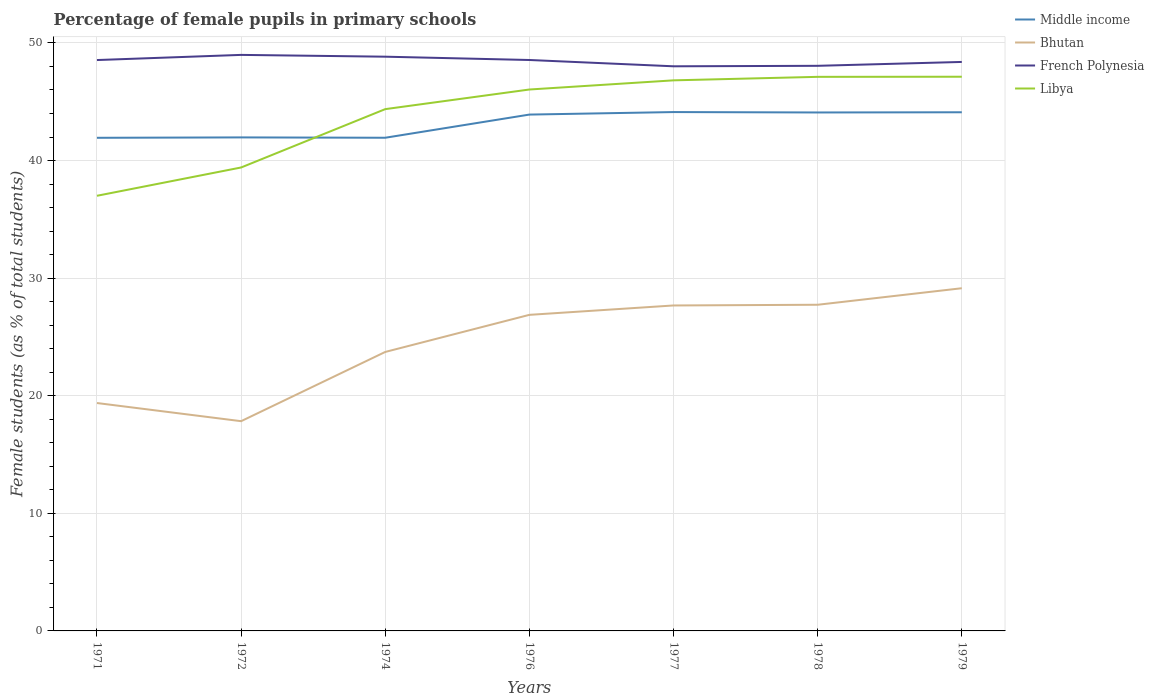Does the line corresponding to Bhutan intersect with the line corresponding to Middle income?
Keep it short and to the point. No. Is the number of lines equal to the number of legend labels?
Your response must be concise. Yes. Across all years, what is the maximum percentage of female pupils in primary schools in Bhutan?
Provide a succinct answer. 17.84. What is the total percentage of female pupils in primary schools in Bhutan in the graph?
Your answer should be compact. -9.84. What is the difference between the highest and the second highest percentage of female pupils in primary schools in Middle income?
Offer a terse response. 2.19. What is the difference between the highest and the lowest percentage of female pupils in primary schools in Middle income?
Make the answer very short. 4. Is the percentage of female pupils in primary schools in Middle income strictly greater than the percentage of female pupils in primary schools in Libya over the years?
Your answer should be very brief. No. How many years are there in the graph?
Make the answer very short. 7. Are the values on the major ticks of Y-axis written in scientific E-notation?
Your response must be concise. No. Does the graph contain any zero values?
Offer a terse response. No. Does the graph contain grids?
Provide a succinct answer. Yes. How many legend labels are there?
Offer a terse response. 4. What is the title of the graph?
Offer a very short reply. Percentage of female pupils in primary schools. What is the label or title of the Y-axis?
Make the answer very short. Female students (as % of total students). What is the Female students (as % of total students) of Middle income in 1971?
Offer a very short reply. 41.93. What is the Female students (as % of total students) in Bhutan in 1971?
Make the answer very short. 19.38. What is the Female students (as % of total students) in French Polynesia in 1971?
Your answer should be very brief. 48.55. What is the Female students (as % of total students) of Libya in 1971?
Give a very brief answer. 37. What is the Female students (as % of total students) in Middle income in 1972?
Make the answer very short. 41.97. What is the Female students (as % of total students) of Bhutan in 1972?
Make the answer very short. 17.84. What is the Female students (as % of total students) in French Polynesia in 1972?
Offer a very short reply. 48.98. What is the Female students (as % of total students) in Libya in 1972?
Offer a terse response. 39.41. What is the Female students (as % of total students) of Middle income in 1974?
Offer a very short reply. 41.94. What is the Female students (as % of total students) of Bhutan in 1974?
Keep it short and to the point. 23.72. What is the Female students (as % of total students) in French Polynesia in 1974?
Your answer should be compact. 48.83. What is the Female students (as % of total students) in Libya in 1974?
Provide a succinct answer. 44.37. What is the Female students (as % of total students) in Middle income in 1976?
Offer a terse response. 43.91. What is the Female students (as % of total students) in Bhutan in 1976?
Offer a very short reply. 26.88. What is the Female students (as % of total students) of French Polynesia in 1976?
Your response must be concise. 48.55. What is the Female students (as % of total students) in Libya in 1976?
Give a very brief answer. 46.04. What is the Female students (as % of total students) of Middle income in 1977?
Provide a short and direct response. 44.12. What is the Female students (as % of total students) in Bhutan in 1977?
Provide a short and direct response. 27.68. What is the Female students (as % of total students) in French Polynesia in 1977?
Offer a terse response. 48.01. What is the Female students (as % of total students) of Libya in 1977?
Your answer should be very brief. 46.82. What is the Female students (as % of total students) in Middle income in 1978?
Your answer should be compact. 44.09. What is the Female students (as % of total students) of Bhutan in 1978?
Offer a very short reply. 27.74. What is the Female students (as % of total students) in French Polynesia in 1978?
Ensure brevity in your answer.  48.06. What is the Female students (as % of total students) in Libya in 1978?
Offer a terse response. 47.12. What is the Female students (as % of total students) in Middle income in 1979?
Make the answer very short. 44.11. What is the Female students (as % of total students) in Bhutan in 1979?
Provide a succinct answer. 29.14. What is the Female students (as % of total students) of French Polynesia in 1979?
Your response must be concise. 48.39. What is the Female students (as % of total students) in Libya in 1979?
Offer a terse response. 47.13. Across all years, what is the maximum Female students (as % of total students) in Middle income?
Your response must be concise. 44.12. Across all years, what is the maximum Female students (as % of total students) of Bhutan?
Provide a succinct answer. 29.14. Across all years, what is the maximum Female students (as % of total students) of French Polynesia?
Your answer should be very brief. 48.98. Across all years, what is the maximum Female students (as % of total students) of Libya?
Provide a short and direct response. 47.13. Across all years, what is the minimum Female students (as % of total students) in Middle income?
Keep it short and to the point. 41.93. Across all years, what is the minimum Female students (as % of total students) of Bhutan?
Offer a very short reply. 17.84. Across all years, what is the minimum Female students (as % of total students) of French Polynesia?
Your answer should be compact. 48.01. Across all years, what is the minimum Female students (as % of total students) of Libya?
Offer a very short reply. 37. What is the total Female students (as % of total students) in Middle income in the graph?
Keep it short and to the point. 302.07. What is the total Female students (as % of total students) of Bhutan in the graph?
Your answer should be compact. 172.37. What is the total Female students (as % of total students) in French Polynesia in the graph?
Your response must be concise. 339.37. What is the total Female students (as % of total students) of Libya in the graph?
Your answer should be compact. 307.89. What is the difference between the Female students (as % of total students) of Middle income in 1971 and that in 1972?
Provide a succinct answer. -0.03. What is the difference between the Female students (as % of total students) in Bhutan in 1971 and that in 1972?
Offer a very short reply. 1.54. What is the difference between the Female students (as % of total students) of French Polynesia in 1971 and that in 1972?
Ensure brevity in your answer.  -0.44. What is the difference between the Female students (as % of total students) of Libya in 1971 and that in 1972?
Give a very brief answer. -2.41. What is the difference between the Female students (as % of total students) of Middle income in 1971 and that in 1974?
Your response must be concise. -0.01. What is the difference between the Female students (as % of total students) of Bhutan in 1971 and that in 1974?
Offer a terse response. -4.34. What is the difference between the Female students (as % of total students) in French Polynesia in 1971 and that in 1974?
Your answer should be very brief. -0.29. What is the difference between the Female students (as % of total students) in Libya in 1971 and that in 1974?
Provide a succinct answer. -7.37. What is the difference between the Female students (as % of total students) of Middle income in 1971 and that in 1976?
Give a very brief answer. -1.97. What is the difference between the Female students (as % of total students) in Bhutan in 1971 and that in 1976?
Offer a terse response. -7.5. What is the difference between the Female students (as % of total students) in French Polynesia in 1971 and that in 1976?
Offer a very short reply. -0. What is the difference between the Female students (as % of total students) of Libya in 1971 and that in 1976?
Your response must be concise. -9.04. What is the difference between the Female students (as % of total students) in Middle income in 1971 and that in 1977?
Give a very brief answer. -2.19. What is the difference between the Female students (as % of total students) in Bhutan in 1971 and that in 1977?
Give a very brief answer. -8.3. What is the difference between the Female students (as % of total students) of French Polynesia in 1971 and that in 1977?
Your answer should be very brief. 0.53. What is the difference between the Female students (as % of total students) of Libya in 1971 and that in 1977?
Offer a terse response. -9.82. What is the difference between the Female students (as % of total students) of Middle income in 1971 and that in 1978?
Keep it short and to the point. -2.15. What is the difference between the Female students (as % of total students) in Bhutan in 1971 and that in 1978?
Keep it short and to the point. -8.36. What is the difference between the Female students (as % of total students) of French Polynesia in 1971 and that in 1978?
Keep it short and to the point. 0.49. What is the difference between the Female students (as % of total students) in Libya in 1971 and that in 1978?
Offer a very short reply. -10.11. What is the difference between the Female students (as % of total students) of Middle income in 1971 and that in 1979?
Offer a terse response. -2.17. What is the difference between the Female students (as % of total students) in Bhutan in 1971 and that in 1979?
Your answer should be very brief. -9.76. What is the difference between the Female students (as % of total students) in French Polynesia in 1971 and that in 1979?
Keep it short and to the point. 0.16. What is the difference between the Female students (as % of total students) of Libya in 1971 and that in 1979?
Keep it short and to the point. -10.12. What is the difference between the Female students (as % of total students) of Middle income in 1972 and that in 1974?
Provide a short and direct response. 0.03. What is the difference between the Female students (as % of total students) in Bhutan in 1972 and that in 1974?
Your answer should be very brief. -5.89. What is the difference between the Female students (as % of total students) of French Polynesia in 1972 and that in 1974?
Provide a short and direct response. 0.15. What is the difference between the Female students (as % of total students) in Libya in 1972 and that in 1974?
Offer a very short reply. -4.96. What is the difference between the Female students (as % of total students) of Middle income in 1972 and that in 1976?
Offer a very short reply. -1.94. What is the difference between the Female students (as % of total students) of Bhutan in 1972 and that in 1976?
Keep it short and to the point. -9.04. What is the difference between the Female students (as % of total students) of French Polynesia in 1972 and that in 1976?
Keep it short and to the point. 0.43. What is the difference between the Female students (as % of total students) of Libya in 1972 and that in 1976?
Offer a terse response. -6.63. What is the difference between the Female students (as % of total students) in Middle income in 1972 and that in 1977?
Offer a very short reply. -2.15. What is the difference between the Female students (as % of total students) in Bhutan in 1972 and that in 1977?
Give a very brief answer. -9.84. What is the difference between the Female students (as % of total students) in French Polynesia in 1972 and that in 1977?
Offer a terse response. 0.97. What is the difference between the Female students (as % of total students) in Libya in 1972 and that in 1977?
Your response must be concise. -7.41. What is the difference between the Female students (as % of total students) of Middle income in 1972 and that in 1978?
Ensure brevity in your answer.  -2.12. What is the difference between the Female students (as % of total students) in Bhutan in 1972 and that in 1978?
Your answer should be compact. -9.9. What is the difference between the Female students (as % of total students) in French Polynesia in 1972 and that in 1978?
Make the answer very short. 0.93. What is the difference between the Female students (as % of total students) of Libya in 1972 and that in 1978?
Provide a short and direct response. -7.71. What is the difference between the Female students (as % of total students) of Middle income in 1972 and that in 1979?
Offer a very short reply. -2.14. What is the difference between the Female students (as % of total students) of Bhutan in 1972 and that in 1979?
Keep it short and to the point. -11.31. What is the difference between the Female students (as % of total students) of French Polynesia in 1972 and that in 1979?
Ensure brevity in your answer.  0.6. What is the difference between the Female students (as % of total students) in Libya in 1972 and that in 1979?
Provide a short and direct response. -7.72. What is the difference between the Female students (as % of total students) in Middle income in 1974 and that in 1976?
Your answer should be compact. -1.97. What is the difference between the Female students (as % of total students) in Bhutan in 1974 and that in 1976?
Your response must be concise. -3.16. What is the difference between the Female students (as % of total students) in French Polynesia in 1974 and that in 1976?
Offer a terse response. 0.28. What is the difference between the Female students (as % of total students) of Libya in 1974 and that in 1976?
Provide a succinct answer. -1.67. What is the difference between the Female students (as % of total students) in Middle income in 1974 and that in 1977?
Your answer should be compact. -2.18. What is the difference between the Female students (as % of total students) of Bhutan in 1974 and that in 1977?
Ensure brevity in your answer.  -3.95. What is the difference between the Female students (as % of total students) in French Polynesia in 1974 and that in 1977?
Provide a short and direct response. 0.82. What is the difference between the Female students (as % of total students) of Libya in 1974 and that in 1977?
Offer a terse response. -2.45. What is the difference between the Female students (as % of total students) of Middle income in 1974 and that in 1978?
Ensure brevity in your answer.  -2.15. What is the difference between the Female students (as % of total students) of Bhutan in 1974 and that in 1978?
Provide a short and direct response. -4.01. What is the difference between the Female students (as % of total students) in French Polynesia in 1974 and that in 1978?
Your answer should be very brief. 0.78. What is the difference between the Female students (as % of total students) in Libya in 1974 and that in 1978?
Offer a very short reply. -2.75. What is the difference between the Female students (as % of total students) of Middle income in 1974 and that in 1979?
Your answer should be compact. -2.17. What is the difference between the Female students (as % of total students) of Bhutan in 1974 and that in 1979?
Keep it short and to the point. -5.42. What is the difference between the Female students (as % of total students) of French Polynesia in 1974 and that in 1979?
Make the answer very short. 0.45. What is the difference between the Female students (as % of total students) in Libya in 1974 and that in 1979?
Your answer should be compact. -2.75. What is the difference between the Female students (as % of total students) in Middle income in 1976 and that in 1977?
Provide a succinct answer. -0.21. What is the difference between the Female students (as % of total students) of Bhutan in 1976 and that in 1977?
Give a very brief answer. -0.8. What is the difference between the Female students (as % of total students) in French Polynesia in 1976 and that in 1977?
Provide a short and direct response. 0.54. What is the difference between the Female students (as % of total students) of Libya in 1976 and that in 1977?
Your response must be concise. -0.78. What is the difference between the Female students (as % of total students) of Middle income in 1976 and that in 1978?
Keep it short and to the point. -0.18. What is the difference between the Female students (as % of total students) of Bhutan in 1976 and that in 1978?
Your response must be concise. -0.86. What is the difference between the Female students (as % of total students) in French Polynesia in 1976 and that in 1978?
Offer a very short reply. 0.49. What is the difference between the Female students (as % of total students) of Libya in 1976 and that in 1978?
Keep it short and to the point. -1.08. What is the difference between the Female students (as % of total students) in Middle income in 1976 and that in 1979?
Provide a succinct answer. -0.2. What is the difference between the Female students (as % of total students) in Bhutan in 1976 and that in 1979?
Offer a terse response. -2.26. What is the difference between the Female students (as % of total students) in French Polynesia in 1976 and that in 1979?
Provide a succinct answer. 0.17. What is the difference between the Female students (as % of total students) of Libya in 1976 and that in 1979?
Ensure brevity in your answer.  -1.09. What is the difference between the Female students (as % of total students) in Middle income in 1977 and that in 1978?
Make the answer very short. 0.03. What is the difference between the Female students (as % of total students) of Bhutan in 1977 and that in 1978?
Your answer should be compact. -0.06. What is the difference between the Female students (as % of total students) in French Polynesia in 1977 and that in 1978?
Offer a terse response. -0.04. What is the difference between the Female students (as % of total students) of Libya in 1977 and that in 1978?
Provide a succinct answer. -0.3. What is the difference between the Female students (as % of total students) of Middle income in 1977 and that in 1979?
Offer a very short reply. 0.02. What is the difference between the Female students (as % of total students) of Bhutan in 1977 and that in 1979?
Give a very brief answer. -1.47. What is the difference between the Female students (as % of total students) of French Polynesia in 1977 and that in 1979?
Give a very brief answer. -0.37. What is the difference between the Female students (as % of total students) of Libya in 1977 and that in 1979?
Give a very brief answer. -0.31. What is the difference between the Female students (as % of total students) of Middle income in 1978 and that in 1979?
Your response must be concise. -0.02. What is the difference between the Female students (as % of total students) of Bhutan in 1978 and that in 1979?
Offer a very short reply. -1.41. What is the difference between the Female students (as % of total students) in French Polynesia in 1978 and that in 1979?
Offer a terse response. -0.33. What is the difference between the Female students (as % of total students) in Libya in 1978 and that in 1979?
Your response must be concise. -0.01. What is the difference between the Female students (as % of total students) of Middle income in 1971 and the Female students (as % of total students) of Bhutan in 1972?
Make the answer very short. 24.1. What is the difference between the Female students (as % of total students) in Middle income in 1971 and the Female students (as % of total students) in French Polynesia in 1972?
Keep it short and to the point. -7.05. What is the difference between the Female students (as % of total students) of Middle income in 1971 and the Female students (as % of total students) of Libya in 1972?
Keep it short and to the point. 2.52. What is the difference between the Female students (as % of total students) of Bhutan in 1971 and the Female students (as % of total students) of French Polynesia in 1972?
Give a very brief answer. -29.6. What is the difference between the Female students (as % of total students) of Bhutan in 1971 and the Female students (as % of total students) of Libya in 1972?
Your answer should be very brief. -20.03. What is the difference between the Female students (as % of total students) in French Polynesia in 1971 and the Female students (as % of total students) in Libya in 1972?
Provide a succinct answer. 9.14. What is the difference between the Female students (as % of total students) in Middle income in 1971 and the Female students (as % of total students) in Bhutan in 1974?
Your response must be concise. 18.21. What is the difference between the Female students (as % of total students) of Middle income in 1971 and the Female students (as % of total students) of French Polynesia in 1974?
Offer a very short reply. -6.9. What is the difference between the Female students (as % of total students) in Middle income in 1971 and the Female students (as % of total students) in Libya in 1974?
Provide a succinct answer. -2.44. What is the difference between the Female students (as % of total students) of Bhutan in 1971 and the Female students (as % of total students) of French Polynesia in 1974?
Offer a very short reply. -29.45. What is the difference between the Female students (as % of total students) of Bhutan in 1971 and the Female students (as % of total students) of Libya in 1974?
Your response must be concise. -24.99. What is the difference between the Female students (as % of total students) of French Polynesia in 1971 and the Female students (as % of total students) of Libya in 1974?
Offer a terse response. 4.17. What is the difference between the Female students (as % of total students) in Middle income in 1971 and the Female students (as % of total students) in Bhutan in 1976?
Provide a short and direct response. 15.05. What is the difference between the Female students (as % of total students) of Middle income in 1971 and the Female students (as % of total students) of French Polynesia in 1976?
Give a very brief answer. -6.62. What is the difference between the Female students (as % of total students) in Middle income in 1971 and the Female students (as % of total students) in Libya in 1976?
Your answer should be compact. -4.11. What is the difference between the Female students (as % of total students) in Bhutan in 1971 and the Female students (as % of total students) in French Polynesia in 1976?
Make the answer very short. -29.17. What is the difference between the Female students (as % of total students) in Bhutan in 1971 and the Female students (as % of total students) in Libya in 1976?
Your answer should be very brief. -26.66. What is the difference between the Female students (as % of total students) of French Polynesia in 1971 and the Female students (as % of total students) of Libya in 1976?
Offer a very short reply. 2.51. What is the difference between the Female students (as % of total students) of Middle income in 1971 and the Female students (as % of total students) of Bhutan in 1977?
Your answer should be very brief. 14.26. What is the difference between the Female students (as % of total students) of Middle income in 1971 and the Female students (as % of total students) of French Polynesia in 1977?
Provide a succinct answer. -6.08. What is the difference between the Female students (as % of total students) in Middle income in 1971 and the Female students (as % of total students) in Libya in 1977?
Your response must be concise. -4.89. What is the difference between the Female students (as % of total students) of Bhutan in 1971 and the Female students (as % of total students) of French Polynesia in 1977?
Provide a short and direct response. -28.63. What is the difference between the Female students (as % of total students) in Bhutan in 1971 and the Female students (as % of total students) in Libya in 1977?
Your answer should be very brief. -27.44. What is the difference between the Female students (as % of total students) in French Polynesia in 1971 and the Female students (as % of total students) in Libya in 1977?
Your response must be concise. 1.73. What is the difference between the Female students (as % of total students) of Middle income in 1971 and the Female students (as % of total students) of Bhutan in 1978?
Provide a short and direct response. 14.2. What is the difference between the Female students (as % of total students) of Middle income in 1971 and the Female students (as % of total students) of French Polynesia in 1978?
Give a very brief answer. -6.12. What is the difference between the Female students (as % of total students) of Middle income in 1971 and the Female students (as % of total students) of Libya in 1978?
Give a very brief answer. -5.18. What is the difference between the Female students (as % of total students) of Bhutan in 1971 and the Female students (as % of total students) of French Polynesia in 1978?
Give a very brief answer. -28.68. What is the difference between the Female students (as % of total students) of Bhutan in 1971 and the Female students (as % of total students) of Libya in 1978?
Your response must be concise. -27.74. What is the difference between the Female students (as % of total students) of French Polynesia in 1971 and the Female students (as % of total students) of Libya in 1978?
Provide a succinct answer. 1.43. What is the difference between the Female students (as % of total students) in Middle income in 1971 and the Female students (as % of total students) in Bhutan in 1979?
Keep it short and to the point. 12.79. What is the difference between the Female students (as % of total students) in Middle income in 1971 and the Female students (as % of total students) in French Polynesia in 1979?
Your answer should be compact. -6.45. What is the difference between the Female students (as % of total students) of Middle income in 1971 and the Female students (as % of total students) of Libya in 1979?
Offer a terse response. -5.19. What is the difference between the Female students (as % of total students) in Bhutan in 1971 and the Female students (as % of total students) in French Polynesia in 1979?
Ensure brevity in your answer.  -29.01. What is the difference between the Female students (as % of total students) in Bhutan in 1971 and the Female students (as % of total students) in Libya in 1979?
Your answer should be compact. -27.75. What is the difference between the Female students (as % of total students) of French Polynesia in 1971 and the Female students (as % of total students) of Libya in 1979?
Make the answer very short. 1.42. What is the difference between the Female students (as % of total students) in Middle income in 1972 and the Female students (as % of total students) in Bhutan in 1974?
Your response must be concise. 18.24. What is the difference between the Female students (as % of total students) in Middle income in 1972 and the Female students (as % of total students) in French Polynesia in 1974?
Provide a short and direct response. -6.86. What is the difference between the Female students (as % of total students) in Middle income in 1972 and the Female students (as % of total students) in Libya in 1974?
Give a very brief answer. -2.4. What is the difference between the Female students (as % of total students) of Bhutan in 1972 and the Female students (as % of total students) of French Polynesia in 1974?
Provide a short and direct response. -31. What is the difference between the Female students (as % of total students) of Bhutan in 1972 and the Female students (as % of total students) of Libya in 1974?
Keep it short and to the point. -26.54. What is the difference between the Female students (as % of total students) in French Polynesia in 1972 and the Female students (as % of total students) in Libya in 1974?
Give a very brief answer. 4.61. What is the difference between the Female students (as % of total students) of Middle income in 1972 and the Female students (as % of total students) of Bhutan in 1976?
Provide a short and direct response. 15.09. What is the difference between the Female students (as % of total students) in Middle income in 1972 and the Female students (as % of total students) in French Polynesia in 1976?
Make the answer very short. -6.58. What is the difference between the Female students (as % of total students) of Middle income in 1972 and the Female students (as % of total students) of Libya in 1976?
Your answer should be compact. -4.07. What is the difference between the Female students (as % of total students) of Bhutan in 1972 and the Female students (as % of total students) of French Polynesia in 1976?
Your response must be concise. -30.71. What is the difference between the Female students (as % of total students) in Bhutan in 1972 and the Female students (as % of total students) in Libya in 1976?
Give a very brief answer. -28.2. What is the difference between the Female students (as % of total students) in French Polynesia in 1972 and the Female students (as % of total students) in Libya in 1976?
Ensure brevity in your answer.  2.94. What is the difference between the Female students (as % of total students) in Middle income in 1972 and the Female students (as % of total students) in Bhutan in 1977?
Your answer should be compact. 14.29. What is the difference between the Female students (as % of total students) in Middle income in 1972 and the Female students (as % of total students) in French Polynesia in 1977?
Offer a terse response. -6.05. What is the difference between the Female students (as % of total students) of Middle income in 1972 and the Female students (as % of total students) of Libya in 1977?
Your response must be concise. -4.85. What is the difference between the Female students (as % of total students) in Bhutan in 1972 and the Female students (as % of total students) in French Polynesia in 1977?
Your response must be concise. -30.18. What is the difference between the Female students (as % of total students) of Bhutan in 1972 and the Female students (as % of total students) of Libya in 1977?
Offer a terse response. -28.98. What is the difference between the Female students (as % of total students) of French Polynesia in 1972 and the Female students (as % of total students) of Libya in 1977?
Make the answer very short. 2.16. What is the difference between the Female students (as % of total students) of Middle income in 1972 and the Female students (as % of total students) of Bhutan in 1978?
Give a very brief answer. 14.23. What is the difference between the Female students (as % of total students) of Middle income in 1972 and the Female students (as % of total students) of French Polynesia in 1978?
Offer a terse response. -6.09. What is the difference between the Female students (as % of total students) of Middle income in 1972 and the Female students (as % of total students) of Libya in 1978?
Your response must be concise. -5.15. What is the difference between the Female students (as % of total students) in Bhutan in 1972 and the Female students (as % of total students) in French Polynesia in 1978?
Offer a terse response. -30.22. What is the difference between the Female students (as % of total students) of Bhutan in 1972 and the Female students (as % of total students) of Libya in 1978?
Make the answer very short. -29.28. What is the difference between the Female students (as % of total students) of French Polynesia in 1972 and the Female students (as % of total students) of Libya in 1978?
Offer a very short reply. 1.87. What is the difference between the Female students (as % of total students) of Middle income in 1972 and the Female students (as % of total students) of Bhutan in 1979?
Make the answer very short. 12.83. What is the difference between the Female students (as % of total students) in Middle income in 1972 and the Female students (as % of total students) in French Polynesia in 1979?
Keep it short and to the point. -6.42. What is the difference between the Female students (as % of total students) in Middle income in 1972 and the Female students (as % of total students) in Libya in 1979?
Keep it short and to the point. -5.16. What is the difference between the Female students (as % of total students) in Bhutan in 1972 and the Female students (as % of total students) in French Polynesia in 1979?
Ensure brevity in your answer.  -30.55. What is the difference between the Female students (as % of total students) in Bhutan in 1972 and the Female students (as % of total students) in Libya in 1979?
Your answer should be very brief. -29.29. What is the difference between the Female students (as % of total students) of French Polynesia in 1972 and the Female students (as % of total students) of Libya in 1979?
Ensure brevity in your answer.  1.86. What is the difference between the Female students (as % of total students) of Middle income in 1974 and the Female students (as % of total students) of Bhutan in 1976?
Make the answer very short. 15.06. What is the difference between the Female students (as % of total students) of Middle income in 1974 and the Female students (as % of total students) of French Polynesia in 1976?
Your response must be concise. -6.61. What is the difference between the Female students (as % of total students) of Middle income in 1974 and the Female students (as % of total students) of Libya in 1976?
Your response must be concise. -4.1. What is the difference between the Female students (as % of total students) in Bhutan in 1974 and the Female students (as % of total students) in French Polynesia in 1976?
Give a very brief answer. -24.83. What is the difference between the Female students (as % of total students) in Bhutan in 1974 and the Female students (as % of total students) in Libya in 1976?
Offer a very short reply. -22.32. What is the difference between the Female students (as % of total students) of French Polynesia in 1974 and the Female students (as % of total students) of Libya in 1976?
Offer a very short reply. 2.79. What is the difference between the Female students (as % of total students) in Middle income in 1974 and the Female students (as % of total students) in Bhutan in 1977?
Offer a very short reply. 14.26. What is the difference between the Female students (as % of total students) in Middle income in 1974 and the Female students (as % of total students) in French Polynesia in 1977?
Give a very brief answer. -6.08. What is the difference between the Female students (as % of total students) in Middle income in 1974 and the Female students (as % of total students) in Libya in 1977?
Your response must be concise. -4.88. What is the difference between the Female students (as % of total students) of Bhutan in 1974 and the Female students (as % of total students) of French Polynesia in 1977?
Provide a short and direct response. -24.29. What is the difference between the Female students (as % of total students) in Bhutan in 1974 and the Female students (as % of total students) in Libya in 1977?
Keep it short and to the point. -23.1. What is the difference between the Female students (as % of total students) in French Polynesia in 1974 and the Female students (as % of total students) in Libya in 1977?
Your answer should be very brief. 2.01. What is the difference between the Female students (as % of total students) of Middle income in 1974 and the Female students (as % of total students) of Bhutan in 1978?
Your answer should be very brief. 14.2. What is the difference between the Female students (as % of total students) in Middle income in 1974 and the Female students (as % of total students) in French Polynesia in 1978?
Provide a succinct answer. -6.12. What is the difference between the Female students (as % of total students) in Middle income in 1974 and the Female students (as % of total students) in Libya in 1978?
Your response must be concise. -5.18. What is the difference between the Female students (as % of total students) of Bhutan in 1974 and the Female students (as % of total students) of French Polynesia in 1978?
Make the answer very short. -24.33. What is the difference between the Female students (as % of total students) of Bhutan in 1974 and the Female students (as % of total students) of Libya in 1978?
Offer a terse response. -23.39. What is the difference between the Female students (as % of total students) of French Polynesia in 1974 and the Female students (as % of total students) of Libya in 1978?
Give a very brief answer. 1.71. What is the difference between the Female students (as % of total students) in Middle income in 1974 and the Female students (as % of total students) in Bhutan in 1979?
Make the answer very short. 12.8. What is the difference between the Female students (as % of total students) in Middle income in 1974 and the Female students (as % of total students) in French Polynesia in 1979?
Your answer should be compact. -6.45. What is the difference between the Female students (as % of total students) in Middle income in 1974 and the Female students (as % of total students) in Libya in 1979?
Give a very brief answer. -5.19. What is the difference between the Female students (as % of total students) of Bhutan in 1974 and the Female students (as % of total students) of French Polynesia in 1979?
Offer a terse response. -24.66. What is the difference between the Female students (as % of total students) in Bhutan in 1974 and the Female students (as % of total students) in Libya in 1979?
Offer a very short reply. -23.4. What is the difference between the Female students (as % of total students) of French Polynesia in 1974 and the Female students (as % of total students) of Libya in 1979?
Your answer should be compact. 1.7. What is the difference between the Female students (as % of total students) of Middle income in 1976 and the Female students (as % of total students) of Bhutan in 1977?
Provide a short and direct response. 16.23. What is the difference between the Female students (as % of total students) in Middle income in 1976 and the Female students (as % of total students) in French Polynesia in 1977?
Keep it short and to the point. -4.11. What is the difference between the Female students (as % of total students) of Middle income in 1976 and the Female students (as % of total students) of Libya in 1977?
Your answer should be very brief. -2.91. What is the difference between the Female students (as % of total students) of Bhutan in 1976 and the Female students (as % of total students) of French Polynesia in 1977?
Offer a very short reply. -21.14. What is the difference between the Female students (as % of total students) of Bhutan in 1976 and the Female students (as % of total students) of Libya in 1977?
Provide a short and direct response. -19.94. What is the difference between the Female students (as % of total students) in French Polynesia in 1976 and the Female students (as % of total students) in Libya in 1977?
Offer a very short reply. 1.73. What is the difference between the Female students (as % of total students) of Middle income in 1976 and the Female students (as % of total students) of Bhutan in 1978?
Your response must be concise. 16.17. What is the difference between the Female students (as % of total students) of Middle income in 1976 and the Female students (as % of total students) of French Polynesia in 1978?
Your answer should be compact. -4.15. What is the difference between the Female students (as % of total students) of Middle income in 1976 and the Female students (as % of total students) of Libya in 1978?
Ensure brevity in your answer.  -3.21. What is the difference between the Female students (as % of total students) in Bhutan in 1976 and the Female students (as % of total students) in French Polynesia in 1978?
Make the answer very short. -21.18. What is the difference between the Female students (as % of total students) in Bhutan in 1976 and the Female students (as % of total students) in Libya in 1978?
Your response must be concise. -20.24. What is the difference between the Female students (as % of total students) in French Polynesia in 1976 and the Female students (as % of total students) in Libya in 1978?
Your response must be concise. 1.43. What is the difference between the Female students (as % of total students) of Middle income in 1976 and the Female students (as % of total students) of Bhutan in 1979?
Provide a succinct answer. 14.77. What is the difference between the Female students (as % of total students) in Middle income in 1976 and the Female students (as % of total students) in French Polynesia in 1979?
Ensure brevity in your answer.  -4.48. What is the difference between the Female students (as % of total students) in Middle income in 1976 and the Female students (as % of total students) in Libya in 1979?
Ensure brevity in your answer.  -3.22. What is the difference between the Female students (as % of total students) of Bhutan in 1976 and the Female students (as % of total students) of French Polynesia in 1979?
Ensure brevity in your answer.  -21.51. What is the difference between the Female students (as % of total students) in Bhutan in 1976 and the Female students (as % of total students) in Libya in 1979?
Offer a terse response. -20.25. What is the difference between the Female students (as % of total students) of French Polynesia in 1976 and the Female students (as % of total students) of Libya in 1979?
Your response must be concise. 1.42. What is the difference between the Female students (as % of total students) in Middle income in 1977 and the Female students (as % of total students) in Bhutan in 1978?
Offer a very short reply. 16.39. What is the difference between the Female students (as % of total students) of Middle income in 1977 and the Female students (as % of total students) of French Polynesia in 1978?
Keep it short and to the point. -3.93. What is the difference between the Female students (as % of total students) of Middle income in 1977 and the Female students (as % of total students) of Libya in 1978?
Your answer should be very brief. -3. What is the difference between the Female students (as % of total students) of Bhutan in 1977 and the Female students (as % of total students) of French Polynesia in 1978?
Make the answer very short. -20.38. What is the difference between the Female students (as % of total students) of Bhutan in 1977 and the Female students (as % of total students) of Libya in 1978?
Offer a terse response. -19.44. What is the difference between the Female students (as % of total students) in French Polynesia in 1977 and the Female students (as % of total students) in Libya in 1978?
Your response must be concise. 0.9. What is the difference between the Female students (as % of total students) in Middle income in 1977 and the Female students (as % of total students) in Bhutan in 1979?
Offer a very short reply. 14.98. What is the difference between the Female students (as % of total students) of Middle income in 1977 and the Female students (as % of total students) of French Polynesia in 1979?
Offer a terse response. -4.26. What is the difference between the Female students (as % of total students) of Middle income in 1977 and the Female students (as % of total students) of Libya in 1979?
Offer a very short reply. -3. What is the difference between the Female students (as % of total students) of Bhutan in 1977 and the Female students (as % of total students) of French Polynesia in 1979?
Provide a short and direct response. -20.71. What is the difference between the Female students (as % of total students) of Bhutan in 1977 and the Female students (as % of total students) of Libya in 1979?
Give a very brief answer. -19.45. What is the difference between the Female students (as % of total students) of French Polynesia in 1977 and the Female students (as % of total students) of Libya in 1979?
Keep it short and to the point. 0.89. What is the difference between the Female students (as % of total students) of Middle income in 1978 and the Female students (as % of total students) of Bhutan in 1979?
Offer a terse response. 14.95. What is the difference between the Female students (as % of total students) in Middle income in 1978 and the Female students (as % of total students) in French Polynesia in 1979?
Offer a terse response. -4.3. What is the difference between the Female students (as % of total students) of Middle income in 1978 and the Female students (as % of total students) of Libya in 1979?
Your answer should be compact. -3.04. What is the difference between the Female students (as % of total students) in Bhutan in 1978 and the Female students (as % of total students) in French Polynesia in 1979?
Your response must be concise. -20.65. What is the difference between the Female students (as % of total students) of Bhutan in 1978 and the Female students (as % of total students) of Libya in 1979?
Offer a terse response. -19.39. What is the difference between the Female students (as % of total students) of French Polynesia in 1978 and the Female students (as % of total students) of Libya in 1979?
Provide a short and direct response. 0.93. What is the average Female students (as % of total students) in Middle income per year?
Offer a very short reply. 43.15. What is the average Female students (as % of total students) in Bhutan per year?
Your answer should be compact. 24.62. What is the average Female students (as % of total students) of French Polynesia per year?
Provide a succinct answer. 48.48. What is the average Female students (as % of total students) in Libya per year?
Provide a succinct answer. 43.98. In the year 1971, what is the difference between the Female students (as % of total students) of Middle income and Female students (as % of total students) of Bhutan?
Offer a very short reply. 22.55. In the year 1971, what is the difference between the Female students (as % of total students) of Middle income and Female students (as % of total students) of French Polynesia?
Provide a succinct answer. -6.61. In the year 1971, what is the difference between the Female students (as % of total students) in Middle income and Female students (as % of total students) in Libya?
Offer a very short reply. 4.93. In the year 1971, what is the difference between the Female students (as % of total students) of Bhutan and Female students (as % of total students) of French Polynesia?
Provide a succinct answer. -29.17. In the year 1971, what is the difference between the Female students (as % of total students) of Bhutan and Female students (as % of total students) of Libya?
Ensure brevity in your answer.  -17.62. In the year 1971, what is the difference between the Female students (as % of total students) in French Polynesia and Female students (as % of total students) in Libya?
Offer a terse response. 11.54. In the year 1972, what is the difference between the Female students (as % of total students) in Middle income and Female students (as % of total students) in Bhutan?
Give a very brief answer. 24.13. In the year 1972, what is the difference between the Female students (as % of total students) of Middle income and Female students (as % of total students) of French Polynesia?
Keep it short and to the point. -7.02. In the year 1972, what is the difference between the Female students (as % of total students) in Middle income and Female students (as % of total students) in Libya?
Provide a short and direct response. 2.56. In the year 1972, what is the difference between the Female students (as % of total students) in Bhutan and Female students (as % of total students) in French Polynesia?
Give a very brief answer. -31.15. In the year 1972, what is the difference between the Female students (as % of total students) in Bhutan and Female students (as % of total students) in Libya?
Give a very brief answer. -21.57. In the year 1972, what is the difference between the Female students (as % of total students) of French Polynesia and Female students (as % of total students) of Libya?
Your answer should be very brief. 9.58. In the year 1974, what is the difference between the Female students (as % of total students) in Middle income and Female students (as % of total students) in Bhutan?
Offer a terse response. 18.22. In the year 1974, what is the difference between the Female students (as % of total students) of Middle income and Female students (as % of total students) of French Polynesia?
Your response must be concise. -6.89. In the year 1974, what is the difference between the Female students (as % of total students) of Middle income and Female students (as % of total students) of Libya?
Provide a short and direct response. -2.43. In the year 1974, what is the difference between the Female students (as % of total students) in Bhutan and Female students (as % of total students) in French Polynesia?
Your response must be concise. -25.11. In the year 1974, what is the difference between the Female students (as % of total students) of Bhutan and Female students (as % of total students) of Libya?
Make the answer very short. -20.65. In the year 1974, what is the difference between the Female students (as % of total students) in French Polynesia and Female students (as % of total students) in Libya?
Ensure brevity in your answer.  4.46. In the year 1976, what is the difference between the Female students (as % of total students) in Middle income and Female students (as % of total students) in Bhutan?
Give a very brief answer. 17.03. In the year 1976, what is the difference between the Female students (as % of total students) of Middle income and Female students (as % of total students) of French Polynesia?
Provide a short and direct response. -4.64. In the year 1976, what is the difference between the Female students (as % of total students) of Middle income and Female students (as % of total students) of Libya?
Provide a succinct answer. -2.13. In the year 1976, what is the difference between the Female students (as % of total students) in Bhutan and Female students (as % of total students) in French Polynesia?
Ensure brevity in your answer.  -21.67. In the year 1976, what is the difference between the Female students (as % of total students) in Bhutan and Female students (as % of total students) in Libya?
Offer a terse response. -19.16. In the year 1976, what is the difference between the Female students (as % of total students) in French Polynesia and Female students (as % of total students) in Libya?
Provide a succinct answer. 2.51. In the year 1977, what is the difference between the Female students (as % of total students) in Middle income and Female students (as % of total students) in Bhutan?
Make the answer very short. 16.45. In the year 1977, what is the difference between the Female students (as % of total students) in Middle income and Female students (as % of total students) in French Polynesia?
Your response must be concise. -3.89. In the year 1977, what is the difference between the Female students (as % of total students) in Middle income and Female students (as % of total students) in Libya?
Keep it short and to the point. -2.7. In the year 1977, what is the difference between the Female students (as % of total students) of Bhutan and Female students (as % of total students) of French Polynesia?
Give a very brief answer. -20.34. In the year 1977, what is the difference between the Female students (as % of total students) of Bhutan and Female students (as % of total students) of Libya?
Offer a very short reply. -19.14. In the year 1977, what is the difference between the Female students (as % of total students) in French Polynesia and Female students (as % of total students) in Libya?
Make the answer very short. 1.19. In the year 1978, what is the difference between the Female students (as % of total students) of Middle income and Female students (as % of total students) of Bhutan?
Keep it short and to the point. 16.35. In the year 1978, what is the difference between the Female students (as % of total students) in Middle income and Female students (as % of total students) in French Polynesia?
Your response must be concise. -3.97. In the year 1978, what is the difference between the Female students (as % of total students) of Middle income and Female students (as % of total students) of Libya?
Offer a terse response. -3.03. In the year 1978, what is the difference between the Female students (as % of total students) of Bhutan and Female students (as % of total students) of French Polynesia?
Your response must be concise. -20.32. In the year 1978, what is the difference between the Female students (as % of total students) of Bhutan and Female students (as % of total students) of Libya?
Provide a succinct answer. -19.38. In the year 1978, what is the difference between the Female students (as % of total students) in French Polynesia and Female students (as % of total students) in Libya?
Your response must be concise. 0.94. In the year 1979, what is the difference between the Female students (as % of total students) of Middle income and Female students (as % of total students) of Bhutan?
Your answer should be very brief. 14.96. In the year 1979, what is the difference between the Female students (as % of total students) in Middle income and Female students (as % of total students) in French Polynesia?
Provide a short and direct response. -4.28. In the year 1979, what is the difference between the Female students (as % of total students) in Middle income and Female students (as % of total students) in Libya?
Ensure brevity in your answer.  -3.02. In the year 1979, what is the difference between the Female students (as % of total students) in Bhutan and Female students (as % of total students) in French Polynesia?
Make the answer very short. -19.24. In the year 1979, what is the difference between the Female students (as % of total students) in Bhutan and Female students (as % of total students) in Libya?
Your answer should be very brief. -17.99. In the year 1979, what is the difference between the Female students (as % of total students) in French Polynesia and Female students (as % of total students) in Libya?
Give a very brief answer. 1.26. What is the ratio of the Female students (as % of total students) of Bhutan in 1971 to that in 1972?
Offer a very short reply. 1.09. What is the ratio of the Female students (as % of total students) of French Polynesia in 1971 to that in 1972?
Offer a very short reply. 0.99. What is the ratio of the Female students (as % of total students) in Libya in 1971 to that in 1972?
Your response must be concise. 0.94. What is the ratio of the Female students (as % of total students) in Bhutan in 1971 to that in 1974?
Offer a very short reply. 0.82. What is the ratio of the Female students (as % of total students) in Libya in 1971 to that in 1974?
Provide a succinct answer. 0.83. What is the ratio of the Female students (as % of total students) in Middle income in 1971 to that in 1976?
Keep it short and to the point. 0.95. What is the ratio of the Female students (as % of total students) of Bhutan in 1971 to that in 1976?
Make the answer very short. 0.72. What is the ratio of the Female students (as % of total students) in French Polynesia in 1971 to that in 1976?
Keep it short and to the point. 1. What is the ratio of the Female students (as % of total students) of Libya in 1971 to that in 1976?
Ensure brevity in your answer.  0.8. What is the ratio of the Female students (as % of total students) in Middle income in 1971 to that in 1977?
Offer a terse response. 0.95. What is the ratio of the Female students (as % of total students) in Bhutan in 1971 to that in 1977?
Ensure brevity in your answer.  0.7. What is the ratio of the Female students (as % of total students) of French Polynesia in 1971 to that in 1977?
Your response must be concise. 1.01. What is the ratio of the Female students (as % of total students) of Libya in 1971 to that in 1977?
Your answer should be compact. 0.79. What is the ratio of the Female students (as % of total students) in Middle income in 1971 to that in 1978?
Provide a succinct answer. 0.95. What is the ratio of the Female students (as % of total students) of Bhutan in 1971 to that in 1978?
Your response must be concise. 0.7. What is the ratio of the Female students (as % of total students) of French Polynesia in 1971 to that in 1978?
Make the answer very short. 1.01. What is the ratio of the Female students (as % of total students) in Libya in 1971 to that in 1978?
Give a very brief answer. 0.79. What is the ratio of the Female students (as % of total students) of Middle income in 1971 to that in 1979?
Ensure brevity in your answer.  0.95. What is the ratio of the Female students (as % of total students) of Bhutan in 1971 to that in 1979?
Offer a very short reply. 0.67. What is the ratio of the Female students (as % of total students) of Libya in 1971 to that in 1979?
Offer a very short reply. 0.79. What is the ratio of the Female students (as % of total students) in Middle income in 1972 to that in 1974?
Your answer should be very brief. 1. What is the ratio of the Female students (as % of total students) of Bhutan in 1972 to that in 1974?
Offer a very short reply. 0.75. What is the ratio of the Female students (as % of total students) of French Polynesia in 1972 to that in 1974?
Your answer should be compact. 1. What is the ratio of the Female students (as % of total students) of Libya in 1972 to that in 1974?
Ensure brevity in your answer.  0.89. What is the ratio of the Female students (as % of total students) in Middle income in 1972 to that in 1976?
Offer a terse response. 0.96. What is the ratio of the Female students (as % of total students) of Bhutan in 1972 to that in 1976?
Your response must be concise. 0.66. What is the ratio of the Female students (as % of total students) in French Polynesia in 1972 to that in 1976?
Your response must be concise. 1.01. What is the ratio of the Female students (as % of total students) in Libya in 1972 to that in 1976?
Provide a short and direct response. 0.86. What is the ratio of the Female students (as % of total students) of Middle income in 1972 to that in 1977?
Ensure brevity in your answer.  0.95. What is the ratio of the Female students (as % of total students) of Bhutan in 1972 to that in 1977?
Keep it short and to the point. 0.64. What is the ratio of the Female students (as % of total students) in French Polynesia in 1972 to that in 1977?
Ensure brevity in your answer.  1.02. What is the ratio of the Female students (as % of total students) in Libya in 1972 to that in 1977?
Your answer should be very brief. 0.84. What is the ratio of the Female students (as % of total students) of Middle income in 1972 to that in 1978?
Offer a very short reply. 0.95. What is the ratio of the Female students (as % of total students) in Bhutan in 1972 to that in 1978?
Offer a very short reply. 0.64. What is the ratio of the Female students (as % of total students) in French Polynesia in 1972 to that in 1978?
Offer a very short reply. 1.02. What is the ratio of the Female students (as % of total students) of Libya in 1972 to that in 1978?
Your answer should be very brief. 0.84. What is the ratio of the Female students (as % of total students) in Middle income in 1972 to that in 1979?
Your response must be concise. 0.95. What is the ratio of the Female students (as % of total students) in Bhutan in 1972 to that in 1979?
Keep it short and to the point. 0.61. What is the ratio of the Female students (as % of total students) in French Polynesia in 1972 to that in 1979?
Provide a succinct answer. 1.01. What is the ratio of the Female students (as % of total students) in Libya in 1972 to that in 1979?
Offer a terse response. 0.84. What is the ratio of the Female students (as % of total students) in Middle income in 1974 to that in 1976?
Ensure brevity in your answer.  0.96. What is the ratio of the Female students (as % of total students) of Bhutan in 1974 to that in 1976?
Make the answer very short. 0.88. What is the ratio of the Female students (as % of total students) in French Polynesia in 1974 to that in 1976?
Keep it short and to the point. 1.01. What is the ratio of the Female students (as % of total students) in Libya in 1974 to that in 1976?
Ensure brevity in your answer.  0.96. What is the ratio of the Female students (as % of total students) of Middle income in 1974 to that in 1977?
Make the answer very short. 0.95. What is the ratio of the Female students (as % of total students) in Bhutan in 1974 to that in 1977?
Make the answer very short. 0.86. What is the ratio of the Female students (as % of total students) in Libya in 1974 to that in 1977?
Provide a short and direct response. 0.95. What is the ratio of the Female students (as % of total students) of Middle income in 1974 to that in 1978?
Ensure brevity in your answer.  0.95. What is the ratio of the Female students (as % of total students) in Bhutan in 1974 to that in 1978?
Keep it short and to the point. 0.86. What is the ratio of the Female students (as % of total students) of French Polynesia in 1974 to that in 1978?
Make the answer very short. 1.02. What is the ratio of the Female students (as % of total students) of Libya in 1974 to that in 1978?
Offer a terse response. 0.94. What is the ratio of the Female students (as % of total students) of Middle income in 1974 to that in 1979?
Provide a succinct answer. 0.95. What is the ratio of the Female students (as % of total students) of Bhutan in 1974 to that in 1979?
Give a very brief answer. 0.81. What is the ratio of the Female students (as % of total students) of French Polynesia in 1974 to that in 1979?
Your answer should be very brief. 1.01. What is the ratio of the Female students (as % of total students) in Libya in 1974 to that in 1979?
Ensure brevity in your answer.  0.94. What is the ratio of the Female students (as % of total students) of Bhutan in 1976 to that in 1977?
Keep it short and to the point. 0.97. What is the ratio of the Female students (as % of total students) in French Polynesia in 1976 to that in 1977?
Provide a succinct answer. 1.01. What is the ratio of the Female students (as % of total students) of Libya in 1976 to that in 1977?
Provide a succinct answer. 0.98. What is the ratio of the Female students (as % of total students) of Bhutan in 1976 to that in 1978?
Your answer should be very brief. 0.97. What is the ratio of the Female students (as % of total students) of French Polynesia in 1976 to that in 1978?
Your answer should be compact. 1.01. What is the ratio of the Female students (as % of total students) in Libya in 1976 to that in 1978?
Give a very brief answer. 0.98. What is the ratio of the Female students (as % of total students) of Middle income in 1976 to that in 1979?
Offer a very short reply. 1. What is the ratio of the Female students (as % of total students) of Bhutan in 1976 to that in 1979?
Offer a terse response. 0.92. What is the ratio of the Female students (as % of total students) in French Polynesia in 1977 to that in 1978?
Make the answer very short. 1. What is the ratio of the Female students (as % of total students) of Middle income in 1977 to that in 1979?
Your answer should be compact. 1. What is the ratio of the Female students (as % of total students) of Bhutan in 1977 to that in 1979?
Your response must be concise. 0.95. What is the ratio of the Female students (as % of total students) of French Polynesia in 1977 to that in 1979?
Offer a terse response. 0.99. What is the ratio of the Female students (as % of total students) of Middle income in 1978 to that in 1979?
Your response must be concise. 1. What is the ratio of the Female students (as % of total students) in Bhutan in 1978 to that in 1979?
Offer a very short reply. 0.95. What is the ratio of the Female students (as % of total students) in French Polynesia in 1978 to that in 1979?
Offer a very short reply. 0.99. What is the difference between the highest and the second highest Female students (as % of total students) in Middle income?
Your answer should be compact. 0.02. What is the difference between the highest and the second highest Female students (as % of total students) in Bhutan?
Give a very brief answer. 1.41. What is the difference between the highest and the second highest Female students (as % of total students) in French Polynesia?
Ensure brevity in your answer.  0.15. What is the difference between the highest and the second highest Female students (as % of total students) of Libya?
Offer a very short reply. 0.01. What is the difference between the highest and the lowest Female students (as % of total students) of Middle income?
Your response must be concise. 2.19. What is the difference between the highest and the lowest Female students (as % of total students) in Bhutan?
Give a very brief answer. 11.31. What is the difference between the highest and the lowest Female students (as % of total students) of French Polynesia?
Provide a short and direct response. 0.97. What is the difference between the highest and the lowest Female students (as % of total students) in Libya?
Make the answer very short. 10.12. 